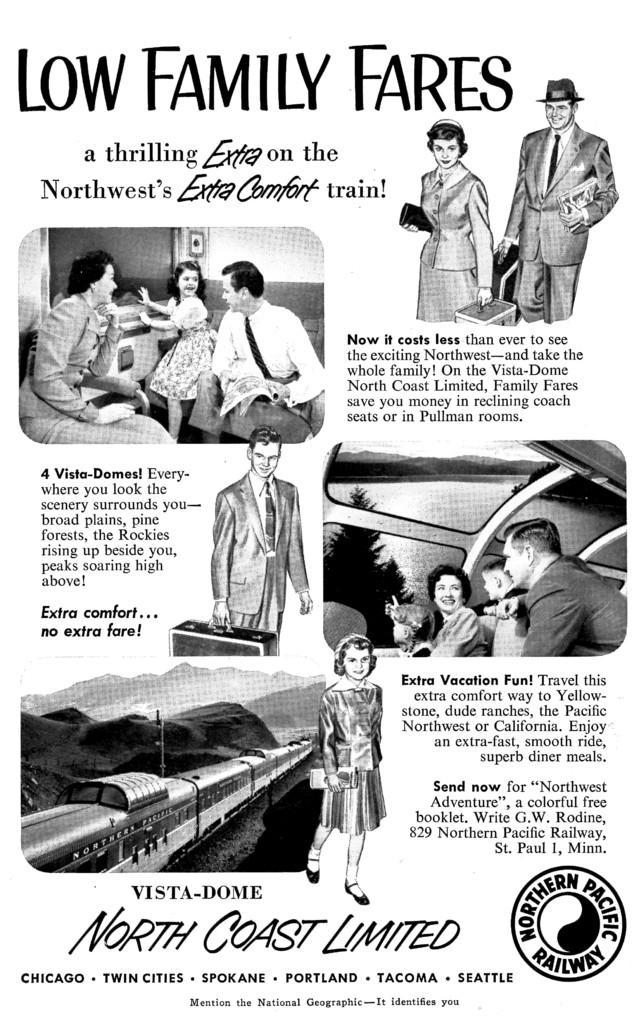Please provide a concise description of this image. In this image there is a printed photo visible , in the photo there is a text, train, hill , logo, tree and the lake visible. 